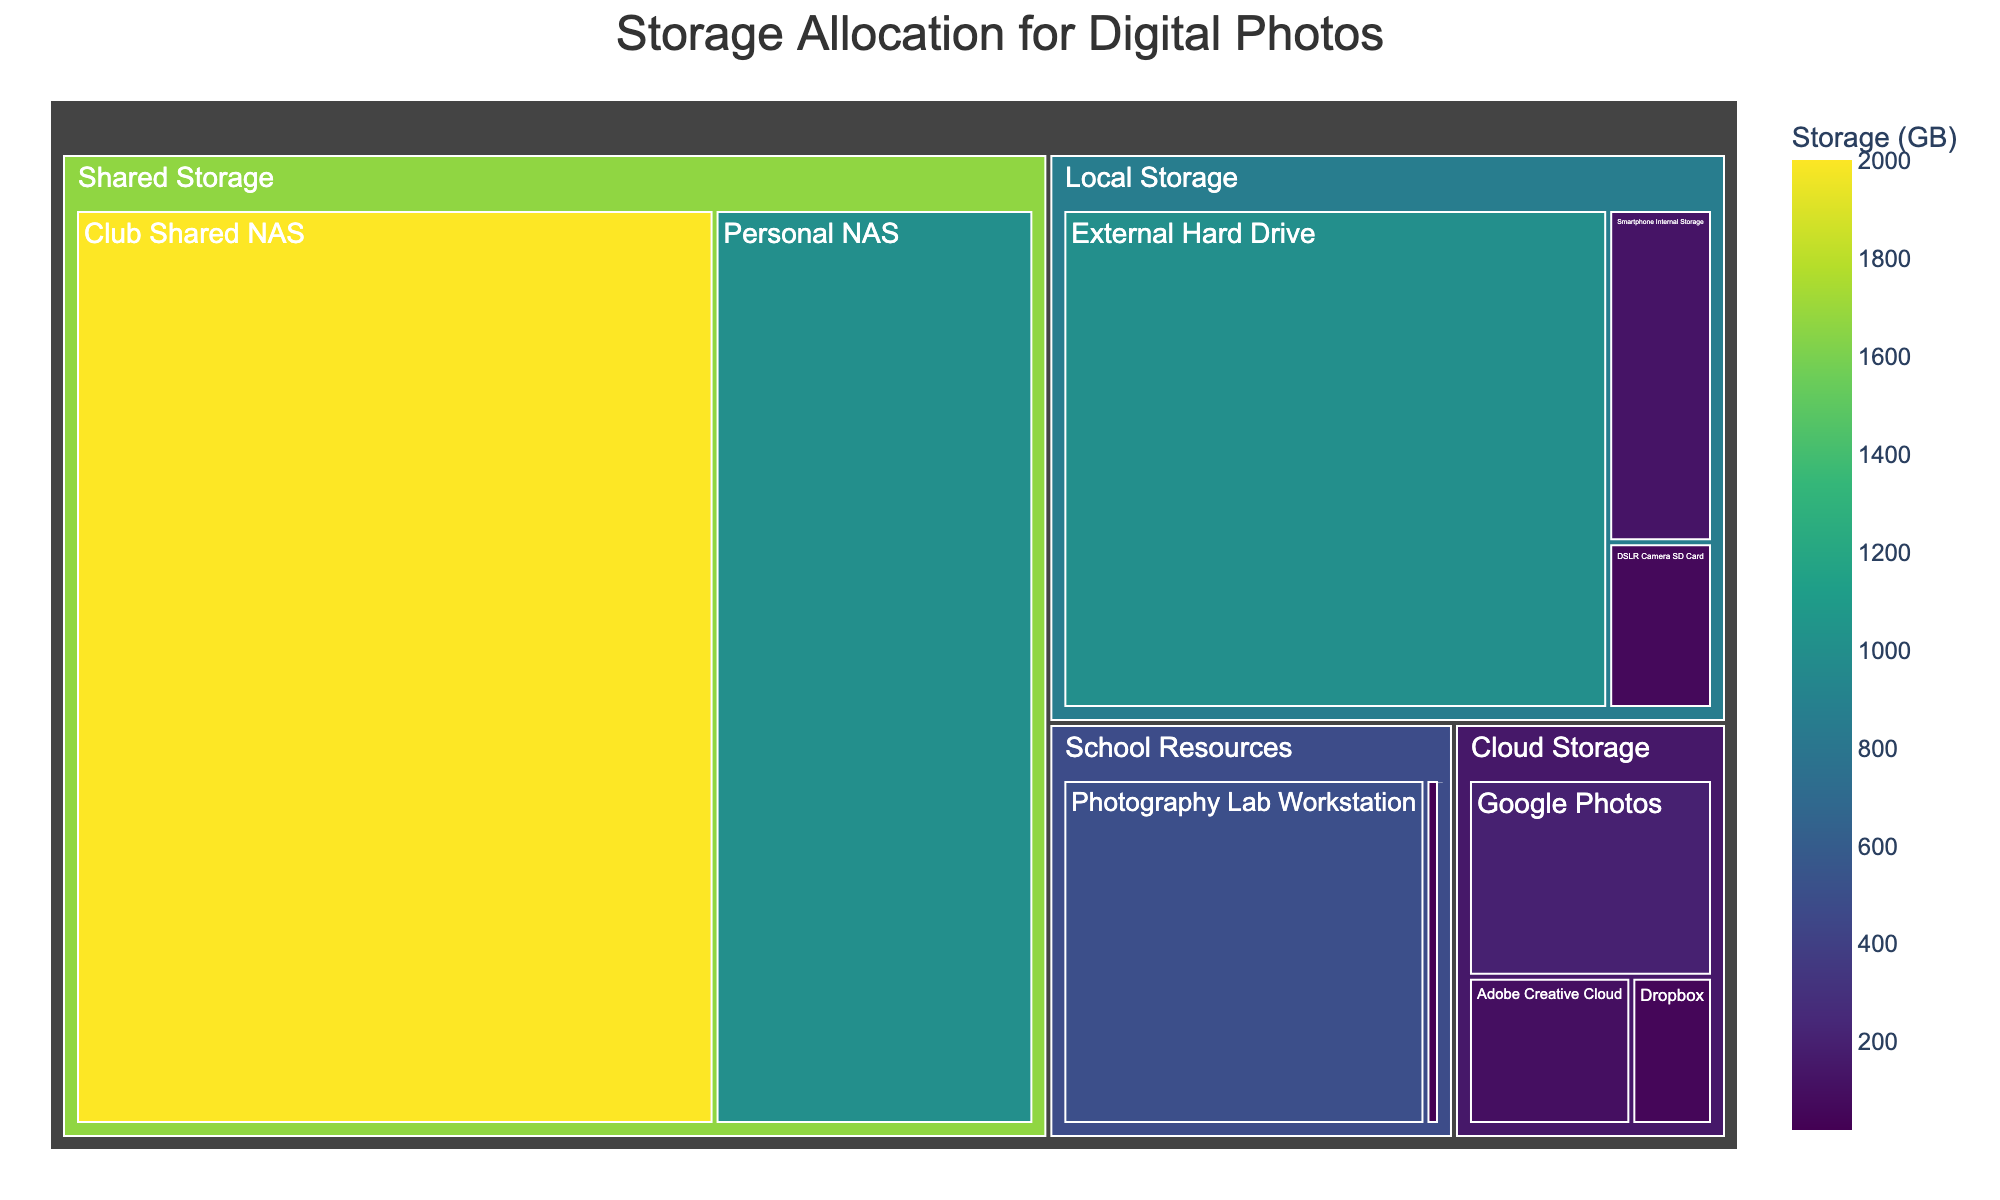Which category has the largest storage allocation? By comparing the areas in the treemap, the "Shared Storage" category has the largest section, indicating it has the largest storage allocation.
Answer: Shared Storage How much storage is allocated to the DSLR Camera SD Card? Look for the "DSLR Camera SD Card" subcategory under "Local Storage" and note the storage amount displayed.
Answer: 64 GB What is the total storage allocation for Local Storage? Sum the storage allocations for the subcategories under "Local Storage": 64 GB (DSLR Camera SD Card) + 128 GB (Smartphone Internal Storage) + 1000 GB (External Hard Drive).
Answer: 1192 GB Which subcategory within School Resources has more storage: University Server or Photography Lab Workstation? Compare the storage allocations for "University Server" and "Photography Lab Workstation" under the "School Resources" category. The "Photography Lab Workstation" has more storage.
Answer: Photography Lab Workstation What is the difference in storage allocation between the Personal NAS and Club Shared NAS? Subtract the storage allocation of "Personal NAS" from "Club Shared NAS" under "Shared Storage": 2000 GB (Club Shared NAS) - 1000 GB (Personal NAS).
Answer: 1000 GB Which has more storage, Google Photos or Dropbox? Compare the storage values for "Google Photos" and "Dropbox" under "Cloud Storage". Google Photos has more storage.
Answer: Google Photos What is the median storage value of all subcategories? List the storage values, sort them, and find the middle value. The sorted values are: 20, 50, 64, 100, 128, 200, 200, 500, 1000, 1000, 2000. The median value is the middle number in the sorted list.
Answer: 200 GB How much total storage is allocated across all categories? Sum the storage values of all subcategories: 64 + 128 + 1000 + 200 + 100 + 50 + 20 + 500 + 2000 + 1000.
Answer: 5062 GB Which category has the least amount of storage allocation? Compare the areas of all categories, the "School Resources" category has the smallest section.
Answer: School Resources 